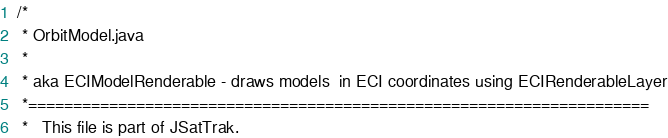Convert code to text. <code><loc_0><loc_0><loc_500><loc_500><_Java_>/*
 * OrbitModel.java
 *
 * aka ECIModelRenderable - draws models  in ECI coordinates using ECIRenderableLayer
 *=====================================================================
 *   This file is part of JSatTrak.</code> 